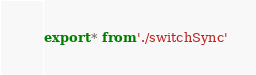Convert code to text. <code><loc_0><loc_0><loc_500><loc_500><_TypeScript_>export * from './switchSync'
</code> 